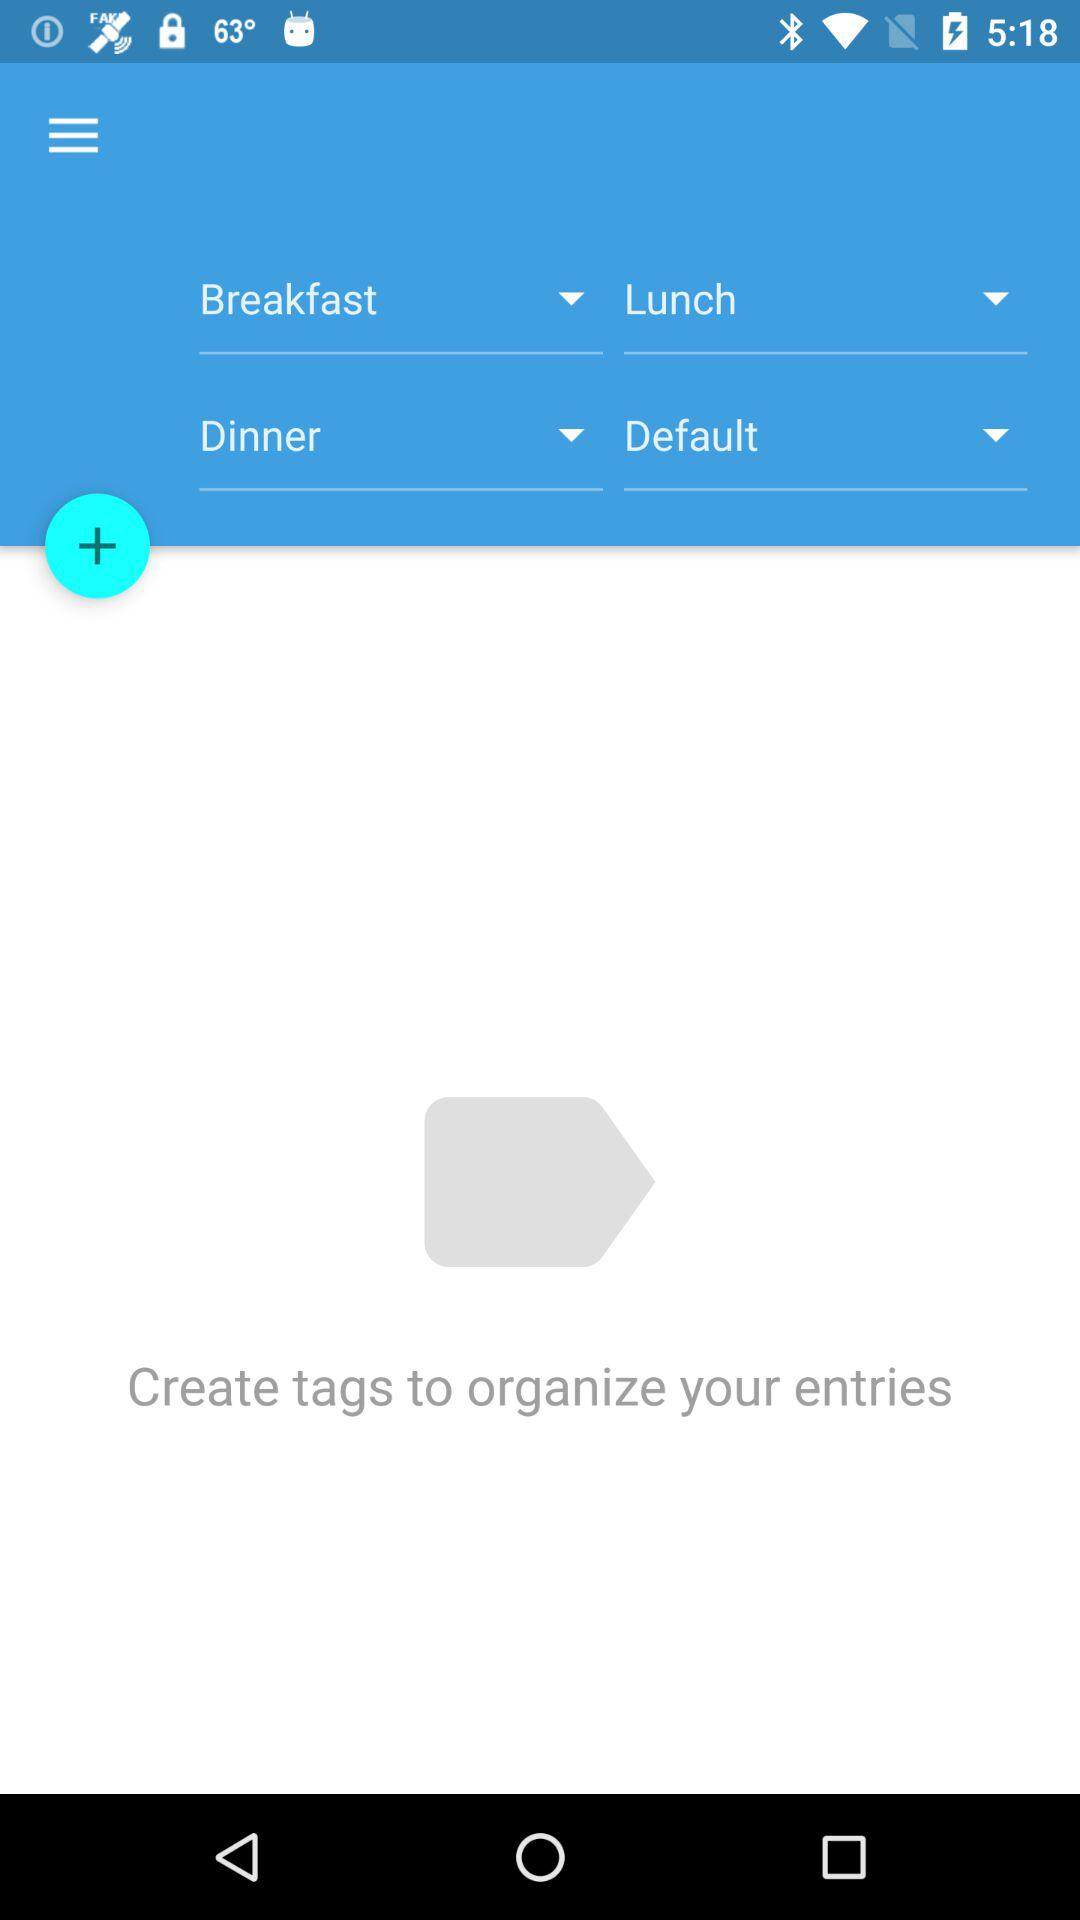How many tags are there in total?
Answer the question using a single word or phrase. 4 